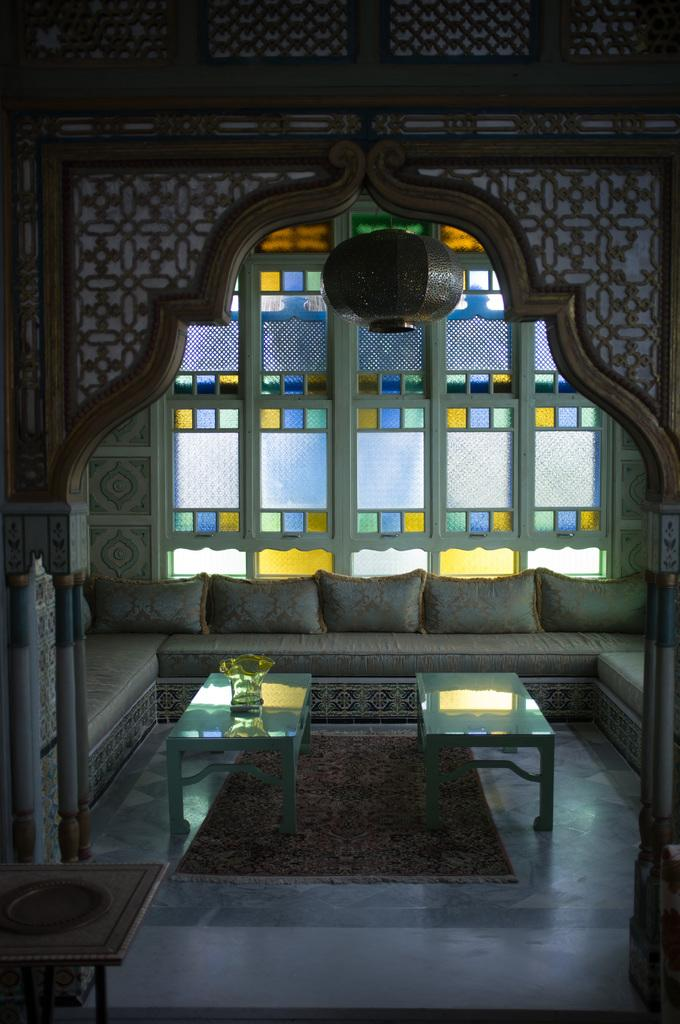What type of furniture can be seen in the image? There are tables and sofas in the image. What is on the sofas? There are cushions on the sofas. Where are the sofas located? The sofas are on the floor. What can be seen in the background of the image? There are windows, lights, and a wall in the background of the image. What might be the setting of the image? The image may have been taken in a hall. What type of rifle is being used by the person in the image? There is no person or rifle present in the image. How much credit is available for the person in the image? There is no reference to credit or financial information in the image. 